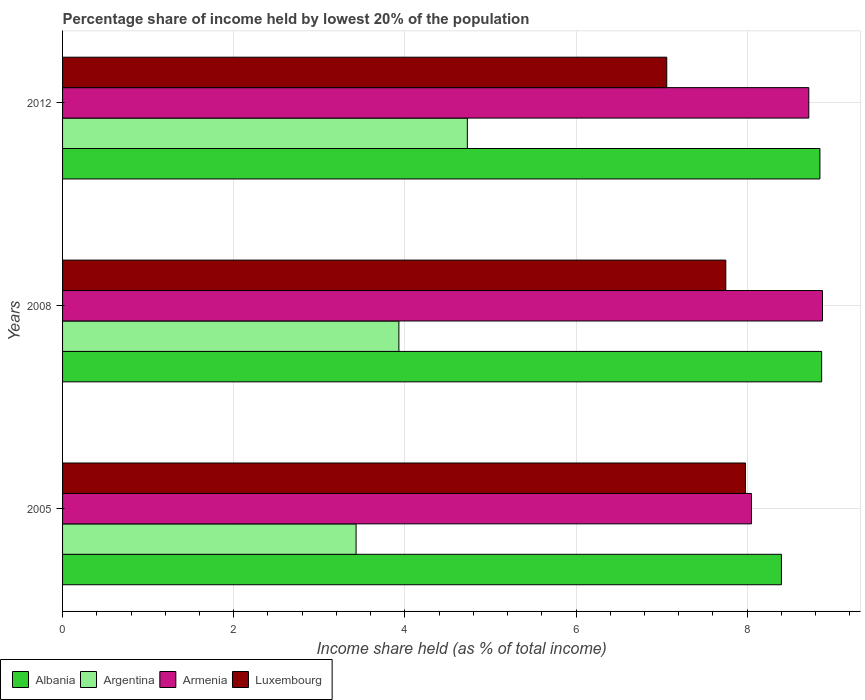How many different coloured bars are there?
Your answer should be very brief. 4. How many groups of bars are there?
Your answer should be compact. 3. Are the number of bars on each tick of the Y-axis equal?
Offer a terse response. Yes. In how many cases, is the number of bars for a given year not equal to the number of legend labels?
Your response must be concise. 0. What is the percentage share of income held by lowest 20% of the population in Luxembourg in 2008?
Keep it short and to the point. 7.75. Across all years, what is the maximum percentage share of income held by lowest 20% of the population in Luxembourg?
Make the answer very short. 7.98. Across all years, what is the minimum percentage share of income held by lowest 20% of the population in Armenia?
Make the answer very short. 8.05. In which year was the percentage share of income held by lowest 20% of the population in Argentina maximum?
Keep it short and to the point. 2012. What is the total percentage share of income held by lowest 20% of the population in Luxembourg in the graph?
Ensure brevity in your answer.  22.79. What is the difference between the percentage share of income held by lowest 20% of the population in Armenia in 2008 and that in 2012?
Your answer should be very brief. 0.16. What is the difference between the percentage share of income held by lowest 20% of the population in Argentina in 2005 and the percentage share of income held by lowest 20% of the population in Armenia in 2008?
Provide a succinct answer. -5.45. What is the average percentage share of income held by lowest 20% of the population in Albania per year?
Offer a very short reply. 8.71. In the year 2012, what is the difference between the percentage share of income held by lowest 20% of the population in Argentina and percentage share of income held by lowest 20% of the population in Albania?
Your answer should be very brief. -4.12. In how many years, is the percentage share of income held by lowest 20% of the population in Armenia greater than 2 %?
Offer a terse response. 3. What is the ratio of the percentage share of income held by lowest 20% of the population in Albania in 2008 to that in 2012?
Offer a terse response. 1. Is the difference between the percentage share of income held by lowest 20% of the population in Argentina in 2008 and 2012 greater than the difference between the percentage share of income held by lowest 20% of the population in Albania in 2008 and 2012?
Give a very brief answer. No. What is the difference between the highest and the second highest percentage share of income held by lowest 20% of the population in Albania?
Give a very brief answer. 0.02. What is the difference between the highest and the lowest percentage share of income held by lowest 20% of the population in Armenia?
Your response must be concise. 0.83. Is the sum of the percentage share of income held by lowest 20% of the population in Argentina in 2005 and 2008 greater than the maximum percentage share of income held by lowest 20% of the population in Armenia across all years?
Your response must be concise. No. What does the 2nd bar from the top in 2012 represents?
Your answer should be very brief. Armenia. What does the 3rd bar from the bottom in 2008 represents?
Your answer should be very brief. Armenia. How many bars are there?
Provide a short and direct response. 12. How many years are there in the graph?
Your answer should be very brief. 3. What is the difference between two consecutive major ticks on the X-axis?
Provide a short and direct response. 2. Are the values on the major ticks of X-axis written in scientific E-notation?
Keep it short and to the point. No. How many legend labels are there?
Ensure brevity in your answer.  4. How are the legend labels stacked?
Offer a terse response. Horizontal. What is the title of the graph?
Your answer should be compact. Percentage share of income held by lowest 20% of the population. What is the label or title of the X-axis?
Keep it short and to the point. Income share held (as % of total income). What is the label or title of the Y-axis?
Your answer should be very brief. Years. What is the Income share held (as % of total income) of Albania in 2005?
Your response must be concise. 8.4. What is the Income share held (as % of total income) in Argentina in 2005?
Your answer should be compact. 3.43. What is the Income share held (as % of total income) in Armenia in 2005?
Your answer should be compact. 8.05. What is the Income share held (as % of total income) in Luxembourg in 2005?
Ensure brevity in your answer.  7.98. What is the Income share held (as % of total income) in Albania in 2008?
Offer a terse response. 8.87. What is the Income share held (as % of total income) in Argentina in 2008?
Make the answer very short. 3.93. What is the Income share held (as % of total income) in Armenia in 2008?
Keep it short and to the point. 8.88. What is the Income share held (as % of total income) of Luxembourg in 2008?
Offer a very short reply. 7.75. What is the Income share held (as % of total income) in Albania in 2012?
Offer a very short reply. 8.85. What is the Income share held (as % of total income) of Argentina in 2012?
Give a very brief answer. 4.73. What is the Income share held (as % of total income) of Armenia in 2012?
Keep it short and to the point. 8.72. What is the Income share held (as % of total income) of Luxembourg in 2012?
Your answer should be compact. 7.06. Across all years, what is the maximum Income share held (as % of total income) of Albania?
Your answer should be very brief. 8.87. Across all years, what is the maximum Income share held (as % of total income) in Argentina?
Your answer should be very brief. 4.73. Across all years, what is the maximum Income share held (as % of total income) of Armenia?
Offer a terse response. 8.88. Across all years, what is the maximum Income share held (as % of total income) of Luxembourg?
Offer a very short reply. 7.98. Across all years, what is the minimum Income share held (as % of total income) of Argentina?
Make the answer very short. 3.43. Across all years, what is the minimum Income share held (as % of total income) of Armenia?
Provide a succinct answer. 8.05. Across all years, what is the minimum Income share held (as % of total income) in Luxembourg?
Your response must be concise. 7.06. What is the total Income share held (as % of total income) in Albania in the graph?
Your answer should be very brief. 26.12. What is the total Income share held (as % of total income) of Argentina in the graph?
Provide a short and direct response. 12.09. What is the total Income share held (as % of total income) in Armenia in the graph?
Provide a succinct answer. 25.65. What is the total Income share held (as % of total income) in Luxembourg in the graph?
Keep it short and to the point. 22.79. What is the difference between the Income share held (as % of total income) of Albania in 2005 and that in 2008?
Offer a terse response. -0.47. What is the difference between the Income share held (as % of total income) of Argentina in 2005 and that in 2008?
Your response must be concise. -0.5. What is the difference between the Income share held (as % of total income) of Armenia in 2005 and that in 2008?
Give a very brief answer. -0.83. What is the difference between the Income share held (as % of total income) in Luxembourg in 2005 and that in 2008?
Keep it short and to the point. 0.23. What is the difference between the Income share held (as % of total income) of Albania in 2005 and that in 2012?
Make the answer very short. -0.45. What is the difference between the Income share held (as % of total income) of Argentina in 2005 and that in 2012?
Your answer should be compact. -1.3. What is the difference between the Income share held (as % of total income) in Armenia in 2005 and that in 2012?
Make the answer very short. -0.67. What is the difference between the Income share held (as % of total income) in Luxembourg in 2005 and that in 2012?
Ensure brevity in your answer.  0.92. What is the difference between the Income share held (as % of total income) of Armenia in 2008 and that in 2012?
Offer a very short reply. 0.16. What is the difference between the Income share held (as % of total income) in Luxembourg in 2008 and that in 2012?
Provide a succinct answer. 0.69. What is the difference between the Income share held (as % of total income) in Albania in 2005 and the Income share held (as % of total income) in Argentina in 2008?
Provide a short and direct response. 4.47. What is the difference between the Income share held (as % of total income) of Albania in 2005 and the Income share held (as % of total income) of Armenia in 2008?
Offer a terse response. -0.48. What is the difference between the Income share held (as % of total income) of Albania in 2005 and the Income share held (as % of total income) of Luxembourg in 2008?
Ensure brevity in your answer.  0.65. What is the difference between the Income share held (as % of total income) in Argentina in 2005 and the Income share held (as % of total income) in Armenia in 2008?
Provide a short and direct response. -5.45. What is the difference between the Income share held (as % of total income) of Argentina in 2005 and the Income share held (as % of total income) of Luxembourg in 2008?
Make the answer very short. -4.32. What is the difference between the Income share held (as % of total income) of Armenia in 2005 and the Income share held (as % of total income) of Luxembourg in 2008?
Provide a short and direct response. 0.3. What is the difference between the Income share held (as % of total income) in Albania in 2005 and the Income share held (as % of total income) in Argentina in 2012?
Your answer should be very brief. 3.67. What is the difference between the Income share held (as % of total income) of Albania in 2005 and the Income share held (as % of total income) of Armenia in 2012?
Offer a very short reply. -0.32. What is the difference between the Income share held (as % of total income) of Albania in 2005 and the Income share held (as % of total income) of Luxembourg in 2012?
Provide a short and direct response. 1.34. What is the difference between the Income share held (as % of total income) of Argentina in 2005 and the Income share held (as % of total income) of Armenia in 2012?
Make the answer very short. -5.29. What is the difference between the Income share held (as % of total income) of Argentina in 2005 and the Income share held (as % of total income) of Luxembourg in 2012?
Ensure brevity in your answer.  -3.63. What is the difference between the Income share held (as % of total income) in Armenia in 2005 and the Income share held (as % of total income) in Luxembourg in 2012?
Your answer should be compact. 0.99. What is the difference between the Income share held (as % of total income) of Albania in 2008 and the Income share held (as % of total income) of Argentina in 2012?
Provide a short and direct response. 4.14. What is the difference between the Income share held (as % of total income) in Albania in 2008 and the Income share held (as % of total income) in Luxembourg in 2012?
Keep it short and to the point. 1.81. What is the difference between the Income share held (as % of total income) of Argentina in 2008 and the Income share held (as % of total income) of Armenia in 2012?
Make the answer very short. -4.79. What is the difference between the Income share held (as % of total income) in Argentina in 2008 and the Income share held (as % of total income) in Luxembourg in 2012?
Keep it short and to the point. -3.13. What is the difference between the Income share held (as % of total income) in Armenia in 2008 and the Income share held (as % of total income) in Luxembourg in 2012?
Make the answer very short. 1.82. What is the average Income share held (as % of total income) of Albania per year?
Keep it short and to the point. 8.71. What is the average Income share held (as % of total income) of Argentina per year?
Give a very brief answer. 4.03. What is the average Income share held (as % of total income) in Armenia per year?
Keep it short and to the point. 8.55. What is the average Income share held (as % of total income) of Luxembourg per year?
Give a very brief answer. 7.6. In the year 2005, what is the difference between the Income share held (as % of total income) of Albania and Income share held (as % of total income) of Argentina?
Make the answer very short. 4.97. In the year 2005, what is the difference between the Income share held (as % of total income) in Albania and Income share held (as % of total income) in Luxembourg?
Your response must be concise. 0.42. In the year 2005, what is the difference between the Income share held (as % of total income) of Argentina and Income share held (as % of total income) of Armenia?
Provide a succinct answer. -4.62. In the year 2005, what is the difference between the Income share held (as % of total income) in Argentina and Income share held (as % of total income) in Luxembourg?
Offer a terse response. -4.55. In the year 2005, what is the difference between the Income share held (as % of total income) in Armenia and Income share held (as % of total income) in Luxembourg?
Offer a terse response. 0.07. In the year 2008, what is the difference between the Income share held (as % of total income) in Albania and Income share held (as % of total income) in Argentina?
Provide a short and direct response. 4.94. In the year 2008, what is the difference between the Income share held (as % of total income) in Albania and Income share held (as % of total income) in Armenia?
Offer a terse response. -0.01. In the year 2008, what is the difference between the Income share held (as % of total income) in Albania and Income share held (as % of total income) in Luxembourg?
Provide a succinct answer. 1.12. In the year 2008, what is the difference between the Income share held (as % of total income) in Argentina and Income share held (as % of total income) in Armenia?
Your answer should be very brief. -4.95. In the year 2008, what is the difference between the Income share held (as % of total income) in Argentina and Income share held (as % of total income) in Luxembourg?
Ensure brevity in your answer.  -3.82. In the year 2008, what is the difference between the Income share held (as % of total income) in Armenia and Income share held (as % of total income) in Luxembourg?
Offer a terse response. 1.13. In the year 2012, what is the difference between the Income share held (as % of total income) in Albania and Income share held (as % of total income) in Argentina?
Make the answer very short. 4.12. In the year 2012, what is the difference between the Income share held (as % of total income) of Albania and Income share held (as % of total income) of Armenia?
Provide a short and direct response. 0.13. In the year 2012, what is the difference between the Income share held (as % of total income) of Albania and Income share held (as % of total income) of Luxembourg?
Your answer should be compact. 1.79. In the year 2012, what is the difference between the Income share held (as % of total income) in Argentina and Income share held (as % of total income) in Armenia?
Give a very brief answer. -3.99. In the year 2012, what is the difference between the Income share held (as % of total income) of Argentina and Income share held (as % of total income) of Luxembourg?
Keep it short and to the point. -2.33. In the year 2012, what is the difference between the Income share held (as % of total income) of Armenia and Income share held (as % of total income) of Luxembourg?
Your answer should be very brief. 1.66. What is the ratio of the Income share held (as % of total income) in Albania in 2005 to that in 2008?
Give a very brief answer. 0.95. What is the ratio of the Income share held (as % of total income) of Argentina in 2005 to that in 2008?
Make the answer very short. 0.87. What is the ratio of the Income share held (as % of total income) in Armenia in 2005 to that in 2008?
Your answer should be compact. 0.91. What is the ratio of the Income share held (as % of total income) in Luxembourg in 2005 to that in 2008?
Give a very brief answer. 1.03. What is the ratio of the Income share held (as % of total income) of Albania in 2005 to that in 2012?
Provide a short and direct response. 0.95. What is the ratio of the Income share held (as % of total income) in Argentina in 2005 to that in 2012?
Make the answer very short. 0.73. What is the ratio of the Income share held (as % of total income) in Armenia in 2005 to that in 2012?
Provide a succinct answer. 0.92. What is the ratio of the Income share held (as % of total income) of Luxembourg in 2005 to that in 2012?
Your response must be concise. 1.13. What is the ratio of the Income share held (as % of total income) of Argentina in 2008 to that in 2012?
Provide a short and direct response. 0.83. What is the ratio of the Income share held (as % of total income) of Armenia in 2008 to that in 2012?
Your answer should be very brief. 1.02. What is the ratio of the Income share held (as % of total income) in Luxembourg in 2008 to that in 2012?
Your response must be concise. 1.1. What is the difference between the highest and the second highest Income share held (as % of total income) in Albania?
Make the answer very short. 0.02. What is the difference between the highest and the second highest Income share held (as % of total income) in Armenia?
Make the answer very short. 0.16. What is the difference between the highest and the second highest Income share held (as % of total income) in Luxembourg?
Offer a terse response. 0.23. What is the difference between the highest and the lowest Income share held (as % of total income) of Albania?
Offer a very short reply. 0.47. What is the difference between the highest and the lowest Income share held (as % of total income) of Armenia?
Offer a very short reply. 0.83. 